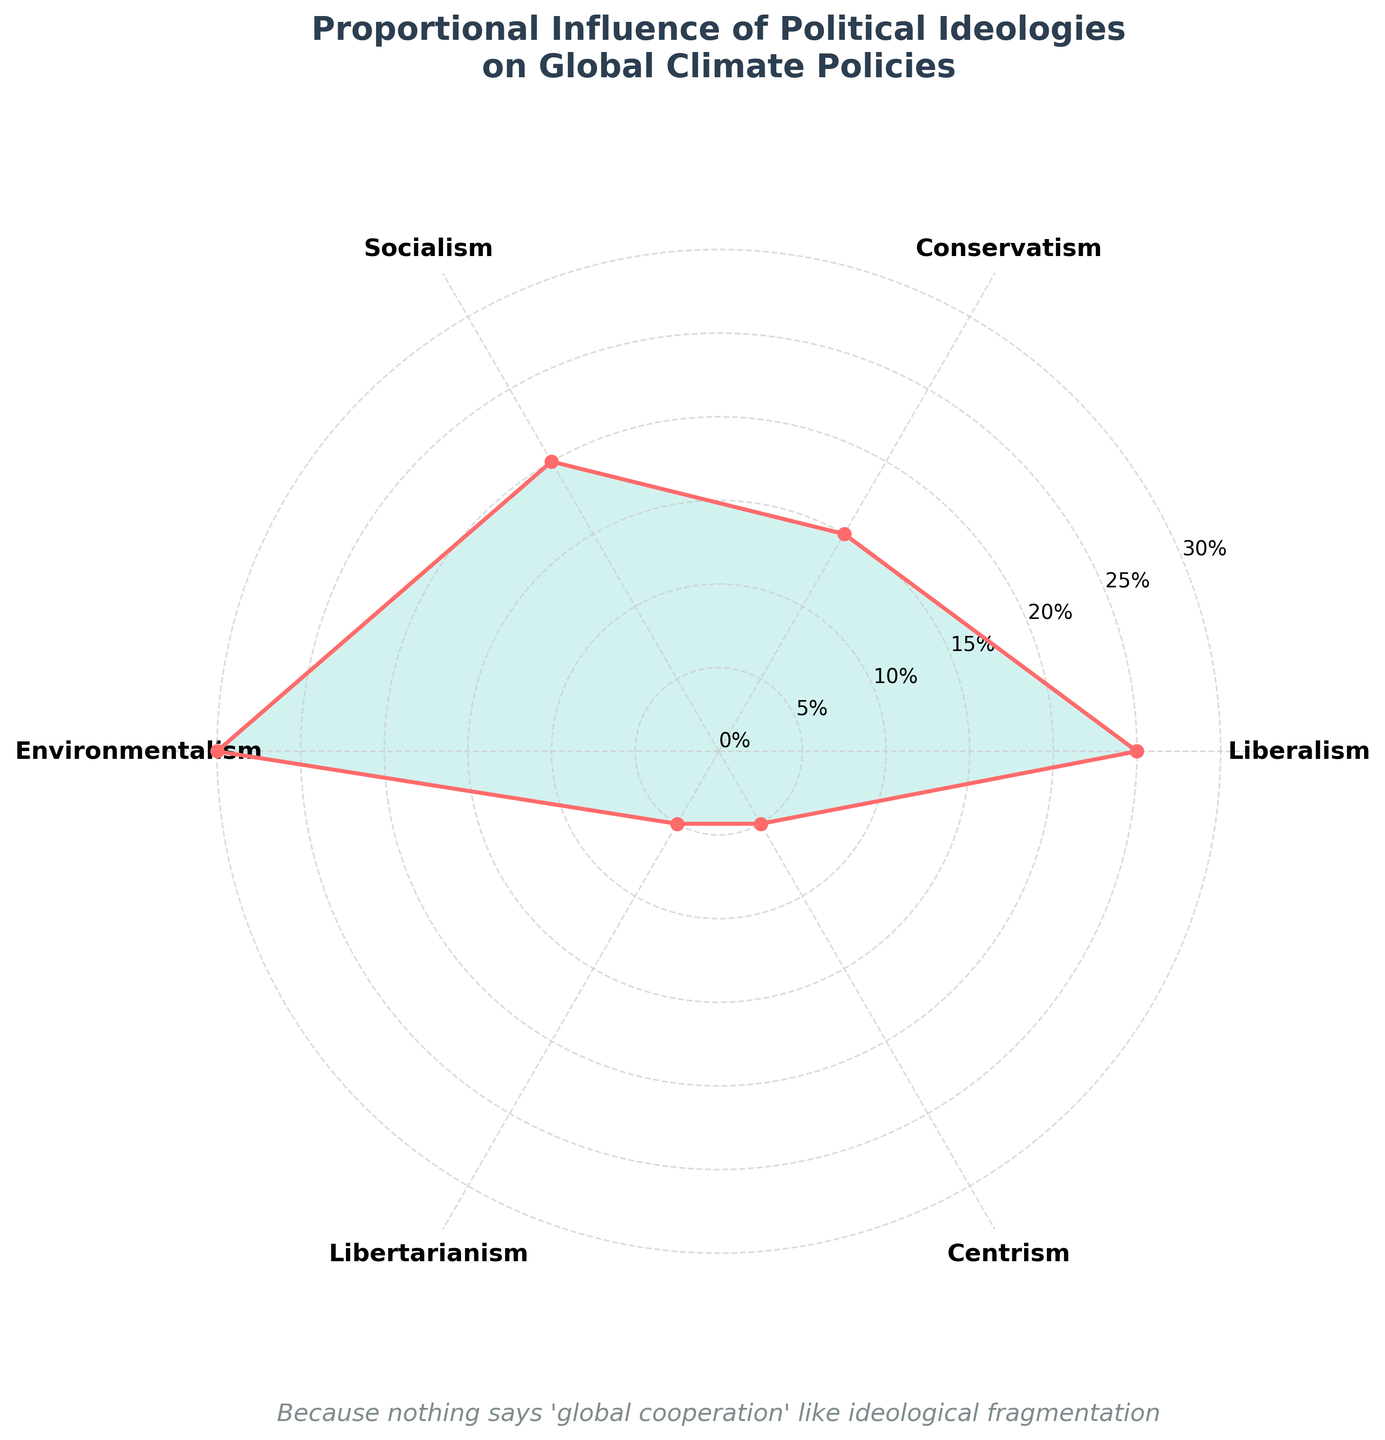What's the title of the chart? The title is prominently displayed at the top of the chart and reads: "Proportional Influence of Political Ideologies on Global Climate Policies"
Answer: Proportional Influence of Political Ideologies on Global Climate Policies Which ideology has the highest influence on global climate policies? The chart shows the influence of each ideology. The highest value is at 30%, which corresponds to Environmentalism.
Answer: Environmentalism What is the combined influence of Liberalism and Socialism? From the chart, the influence of Liberalism is 25% and the influence of Socialism is 20%. Summing these values gives 25% + 20% = 45%
Answer: 45% How does the influence of Conservatism compare to Libertarianism? The chart shows the influence of Conservatism is 15%, and Libertarianism is 5%. Comparing these values, Conservatism has a higher influence than Libertarianism.
Answer: Conservatism has a higher influence Which ideologies have an influence less than 10%? Identifying the segments from the chart, Libertarianism and Centrism each have 5% influence, which is less than 10%.
Answer: Libertarianism and Centrism What is the difference in influence between Environmentalism and Conservatism? According to the chart, the influence of Environmentalism is 30%, and the influence of Conservatism is 15%. Subtracting these values gives 30% - 15% = 15%.
Answer: 15% What are the ideologies with influence percentages above the average? The sum of influences from the rose chart is 100% for 6 ideologies. The average influence is 100% / 6 = approximately 16.67%. Ideologies above this average are Liberalism (25%), Socialism (20%), and Environmentalism (30%).
Answer: Liberalism, Socialism, Environmentalism By how much does the influence of Environmentalism exceed that of Socialism? From the chart, Environmentalism is at 30%, and Socialism is at 20%. Calculating the difference gives 30% - 20% = 10%.
Answer: 10% What is the total combined influence of ideologies with less than 7% influence? From the chart, Libertarianism and Centrism each have 5% influence. Summing these values gives 5% + 5% = 10%.
Answer: 10% What is the subtitle of the chart? The subtitle is located below the title and reads: "Because nothing says 'global cooperation' like ideological fragmentation".
Answer: Because nothing says 'global cooperation' like ideological fragmentation 